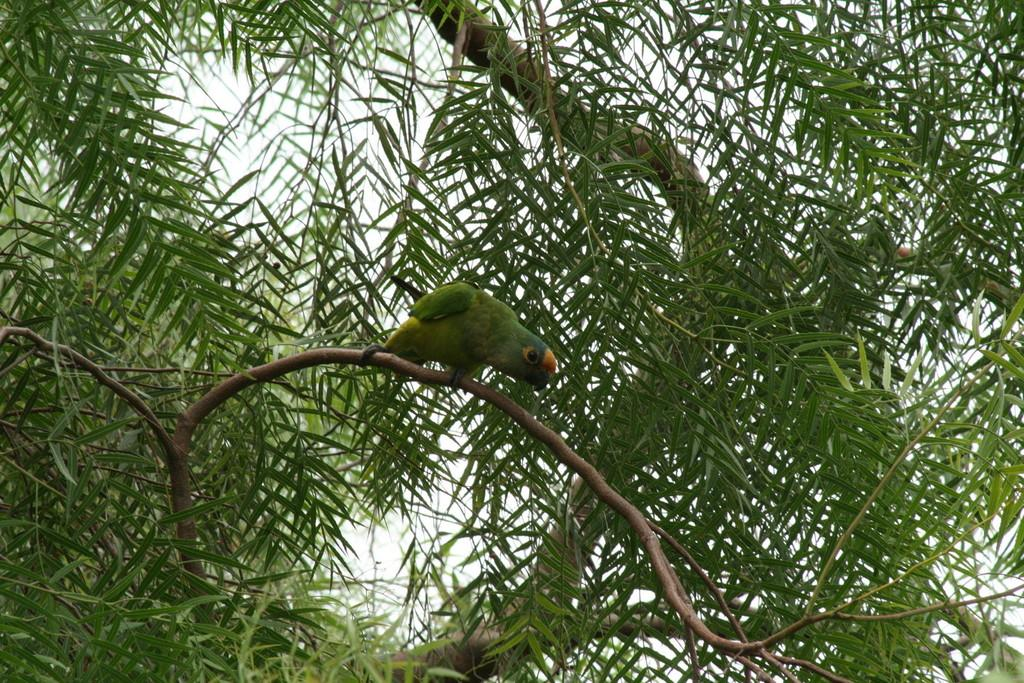What type of animal is in the image? There is a bird in the image. Where is the bird located? The bird is sitting on a branch of a tree. What color is the bird? The bird is green in color. What can be seen in the background of the image? There are trees and the sky visible in the background of the image. How does the bird compare to a car in terms of speed in the image? The image does not provide any information about the speed of the bird or a car, so it is not possible to make a comparison. 